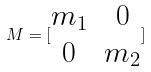<formula> <loc_0><loc_0><loc_500><loc_500>M = [ \begin{matrix} m _ { 1 } & 0 \\ 0 & m _ { 2 } \end{matrix} ]</formula> 